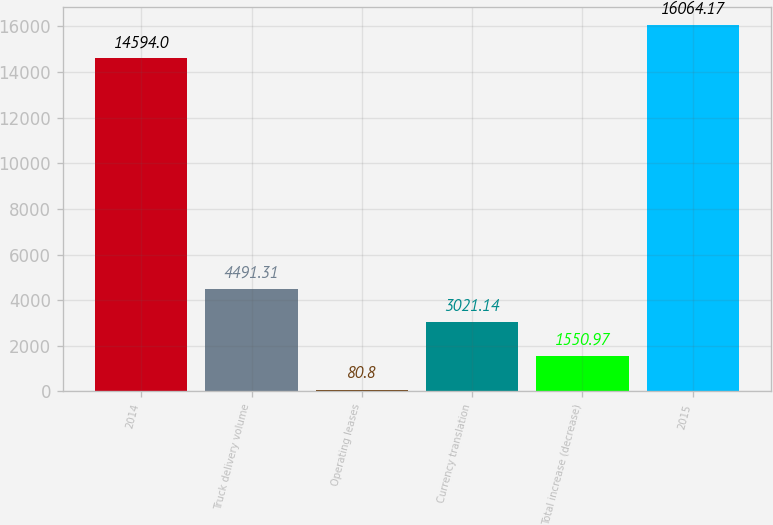Convert chart to OTSL. <chart><loc_0><loc_0><loc_500><loc_500><bar_chart><fcel>2014<fcel>Truck delivery volume<fcel>Operating leases<fcel>Currency translation<fcel>Total increase (decrease)<fcel>2015<nl><fcel>14594<fcel>4491.31<fcel>80.8<fcel>3021.14<fcel>1550.97<fcel>16064.2<nl></chart> 